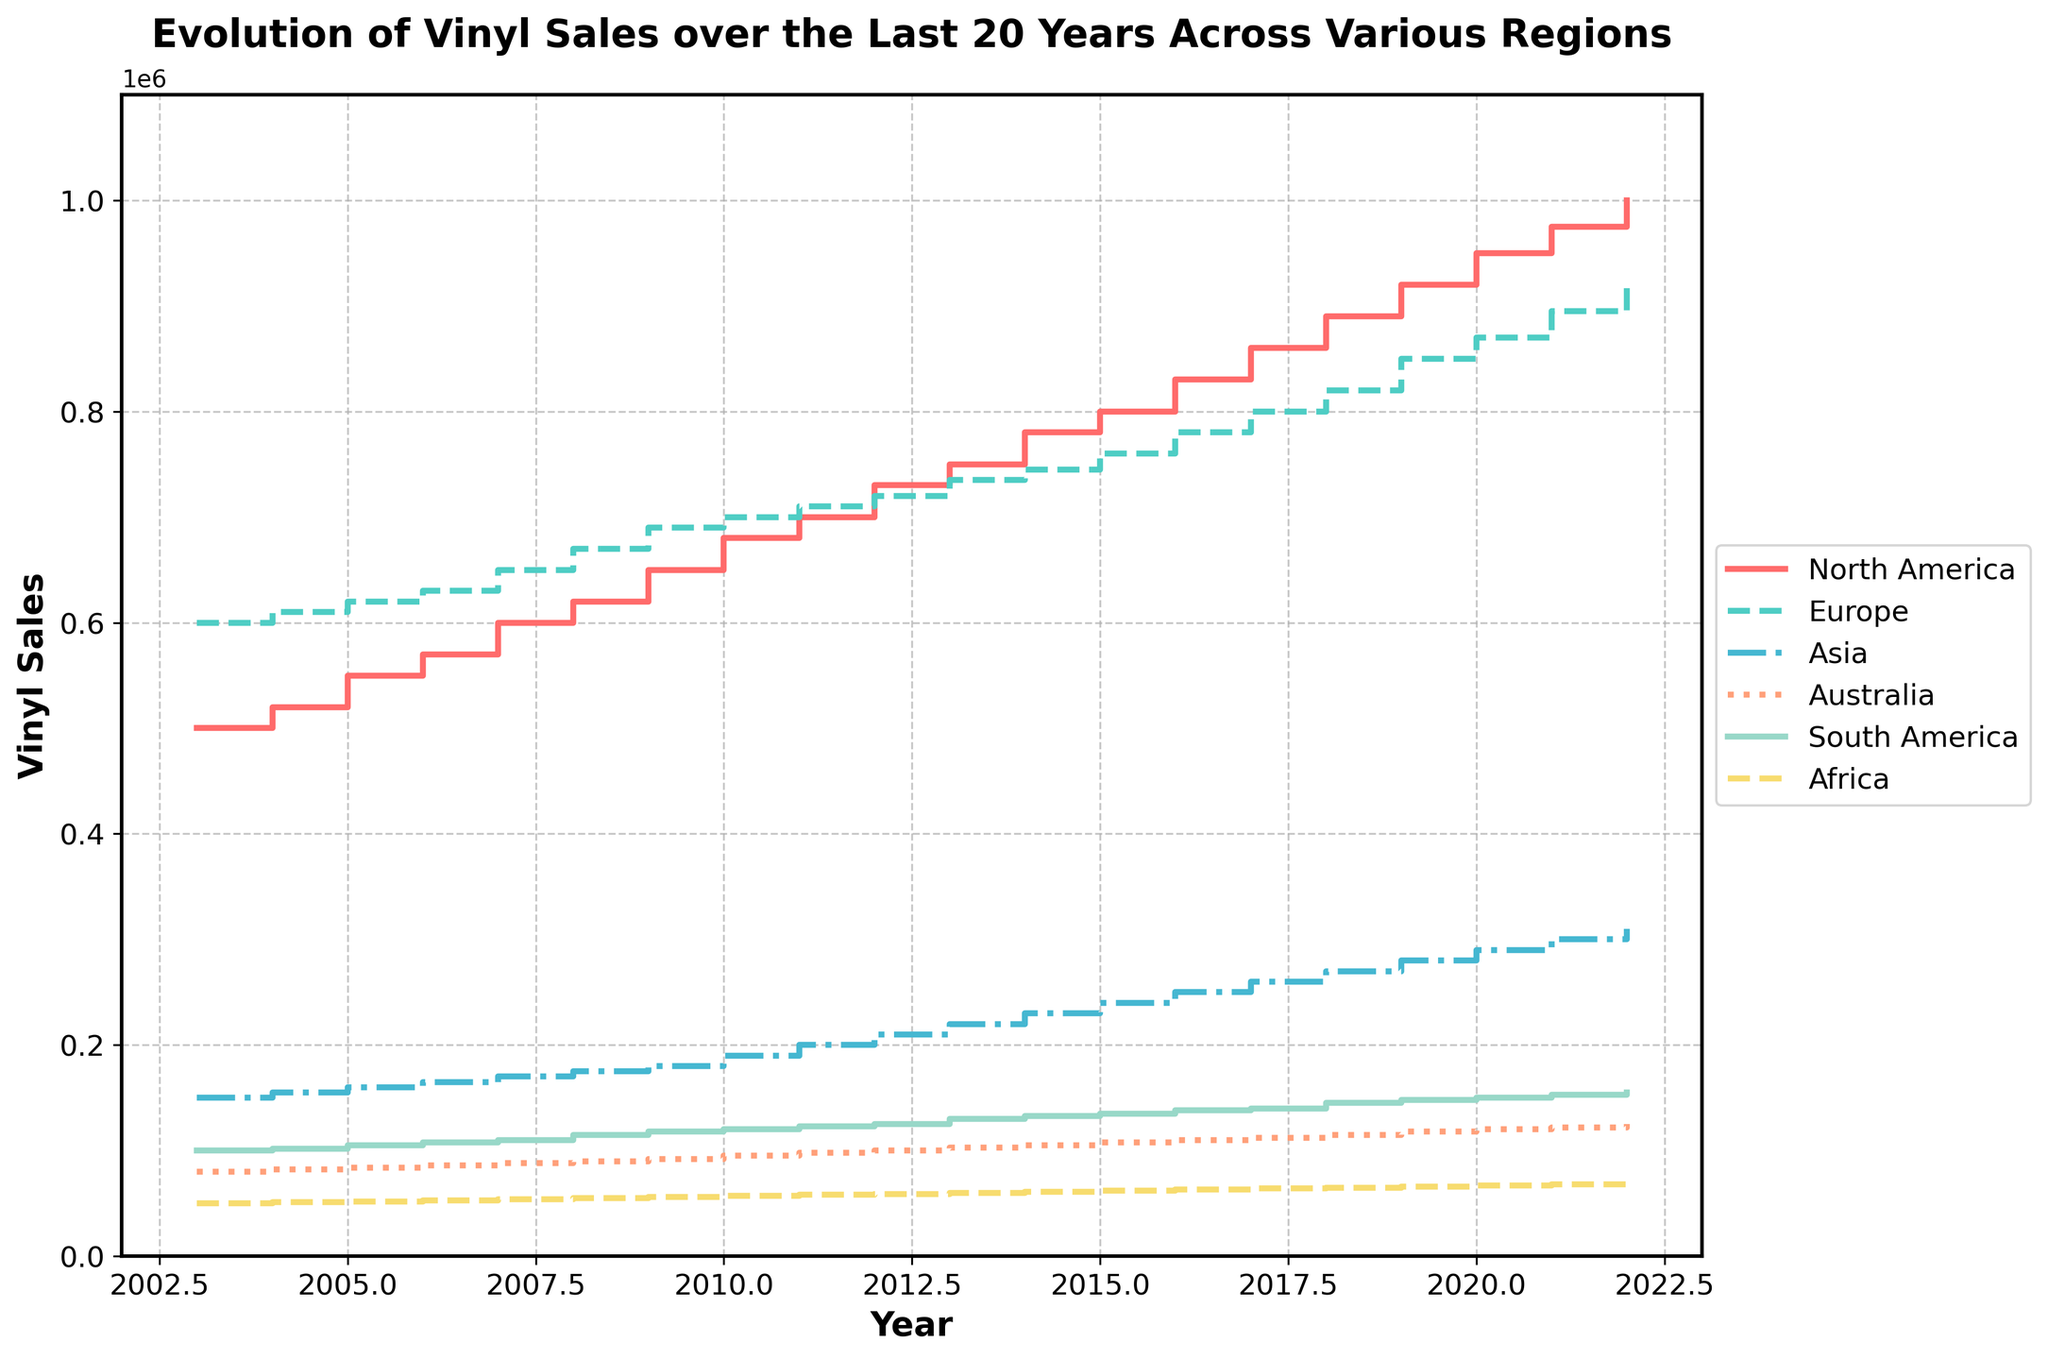What is the title of the figure? The title of a figure is generally placed at the top of the plot. Look at the top central part of the figure to locate the title. The title should be broad enough to explain the overall context of the plot.
Answer: Evolution of Vinyl Sales over the Last 20 Years Across Various Regions What does the x-axis represent? The x-axis typically represents the horizontal dimension of the plot and is labeled to describe what it quantifies. From the data provided, the x-axis seems to represent the year in which the vinyl sales were recorded.
Answer: Year Which region had the highest vinyl sales in 2022? To determine this, locate the data points for 2022 on the right-hand side of the plot and compare the heights of the steps for each region. The region with the highest value will have the tallest step.
Answer: North America By how much did vinyl sales in North America increase from 2003 to 2022? Find the value of vinyl sales in North America for 2003 and 2022 from the plot. Subtract the 2003 value from the 2022 value to find the increase. 1,000,000 - 500,000 = 500,000
Answer: 500,000 Which region has the lowest vinyl sales growth from 2003 to 2022? To determine vinyl sales growth by region, we compare the initial and final sales values across these years. Identify the least difference between 2022 and 2003 for each region.
Answer: Africa In which year did Europe see the highest increase in vinyl sales compared to the previous year? Examine the steps for the Europe region and identify the year with the steepest upward step compared to the previous year. Look for the largest vertical difference between consecutive years' steps.
Answer: 2019 What is the average vinyl sales in Asia over the period from 2003 to 2022? Calculate the average by summing the vinyl sales values for Asia from 2003 to 2022 and dividing by the number of years. (150,000 + 155,000 + 160,000 + 165,000 + 170,000 + 175,000 + 180,000 + 190,000 + 200,000 + 210,000 + 220,000 + 230,000 + 240,000 + 250,000 + 260,000 + 270,000 + 280,000 + 290,000 + 300,000 + 310,000) / 20 = 220,750
Answer: 220,750 Which region shows the most consistent growth in vinyl sales? Consistent growth can be identified by looking for a series of uniform, evenly spaced steps without large jumps or drops. Assess the regularity of steps in each region's plot line.
Answer: Europe Are there any regions where vinyl sales decreased in any of the years shown? To find this information, examine the steps for each region. If a step goes downward, this indicates a decrease in sales. Check for any such downward steps in the entire plot.
Answer: No 